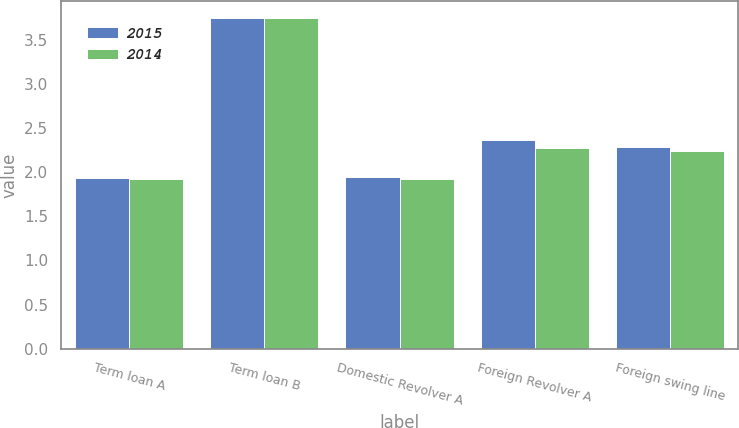Convert chart to OTSL. <chart><loc_0><loc_0><loc_500><loc_500><stacked_bar_chart><ecel><fcel>Term loan A<fcel>Term loan B<fcel>Domestic Revolver A<fcel>Foreign Revolver A<fcel>Foreign swing line<nl><fcel>2015<fcel>1.94<fcel>3.75<fcel>1.95<fcel>2.36<fcel>2.29<nl><fcel>2014<fcel>1.92<fcel>3.75<fcel>1.92<fcel>2.27<fcel>2.24<nl></chart> 